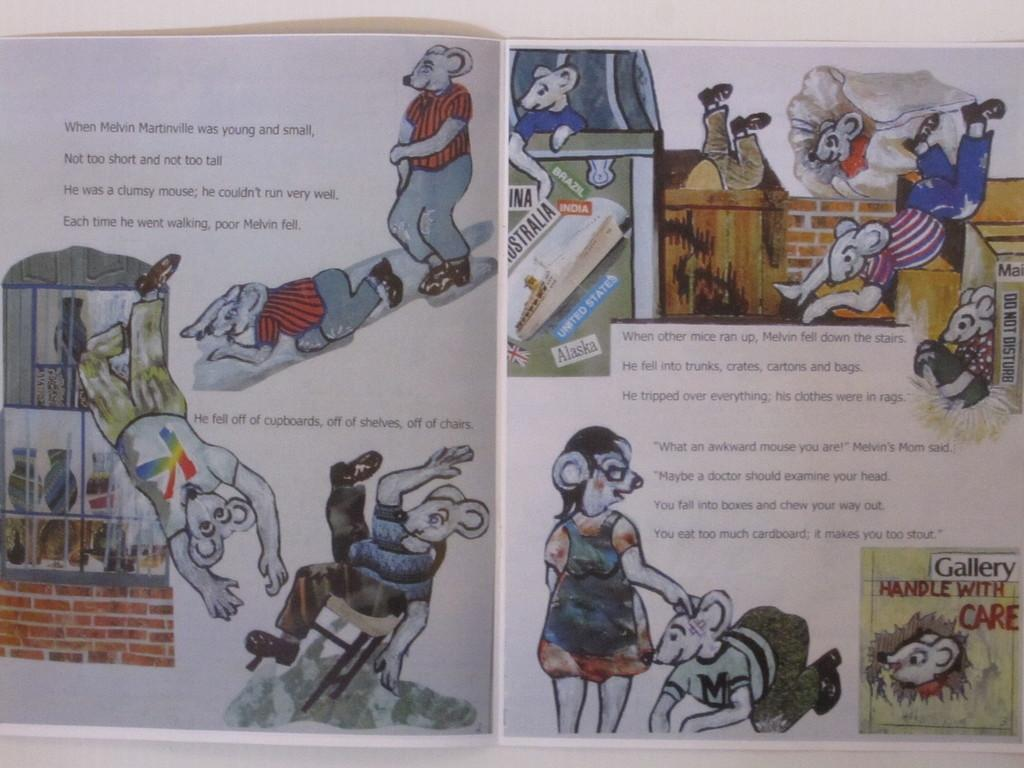Provide a one-sentence caption for the provided image. A book about a mouse named Melvin Martinville is opened. 